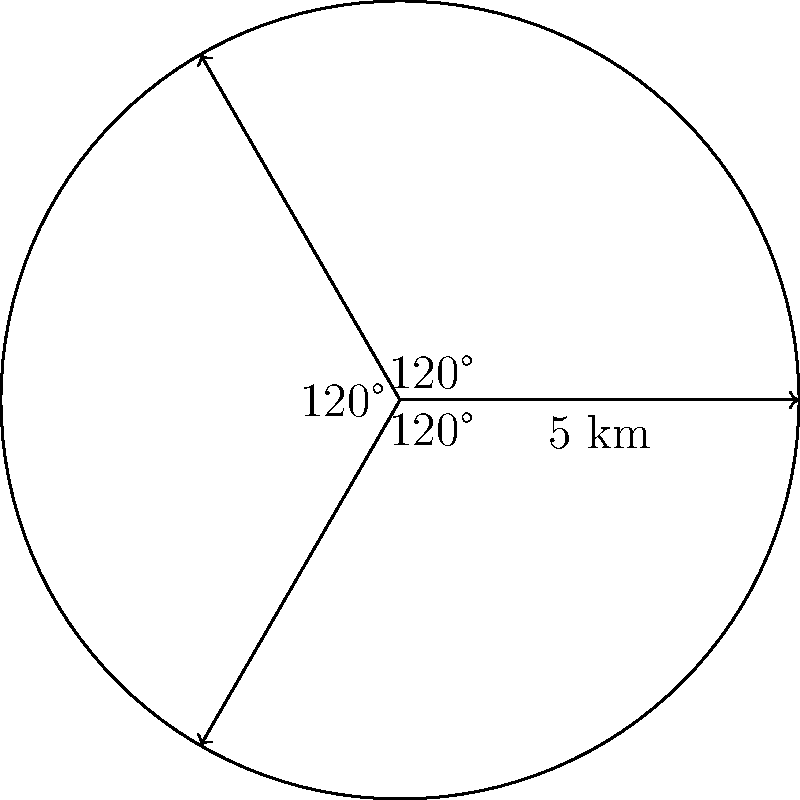In a peacekeeping operation, communication equipment is set up at a central location to cover three non-overlapping sectors, each spanning 120°. If the maximum range of the equipment is 5 km, what is the total area covered by the communication system? Round your answer to the nearest square kilometer. To solve this problem, we need to follow these steps:

1) The area of a full circle is given by the formula $A = \pi r^2$, where $r$ is the radius.

2) In this case, $r = 5$ km, so the area of a full circle would be:
   $A = \pi (5)^2 = 25\pi$ km²

3) However, we're only dealing with three 120° sectors, which together make up the entire circle.

4) The area of a sector is proportional to its central angle. A 120° sector is $\frac{120}{360} = \frac{1}{3}$ of a full circle.

5) Therefore, the area of each 120° sector is:
   $\frac{1}{3} \times 25\pi = \frac{25\pi}{3}$ km²

6) Since there are three such sectors, the total area is:
   $3 \times \frac{25\pi}{3} = 25\pi$ km²

7) Calculating this:
   $25\pi \approx 78.54$ km²

8) Rounding to the nearest square kilometer:
   $78.54$ km² ≈ 79 km²
Answer: 79 km² 